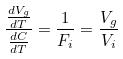<formula> <loc_0><loc_0><loc_500><loc_500>\frac { \frac { d V _ { g } } { d T } } { \frac { d C } { d T } } = \frac { 1 } { F _ { i } } = \frac { V _ { g } } { V _ { i } }</formula> 